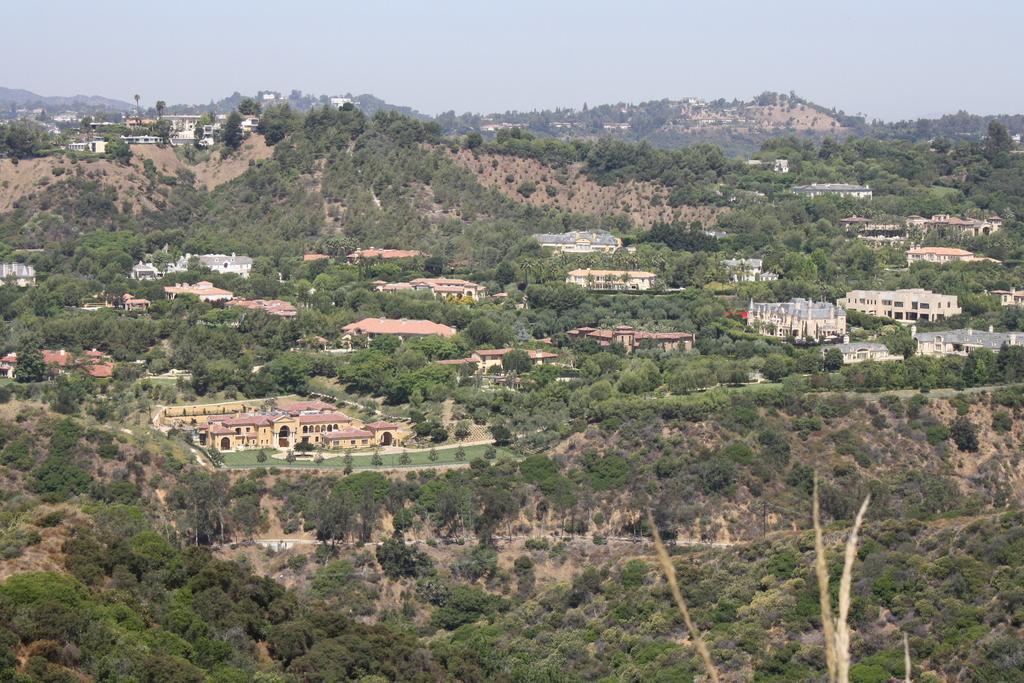Please provide a concise description of this image. In this image we can see sky, hills, buildings, trees and towers. 